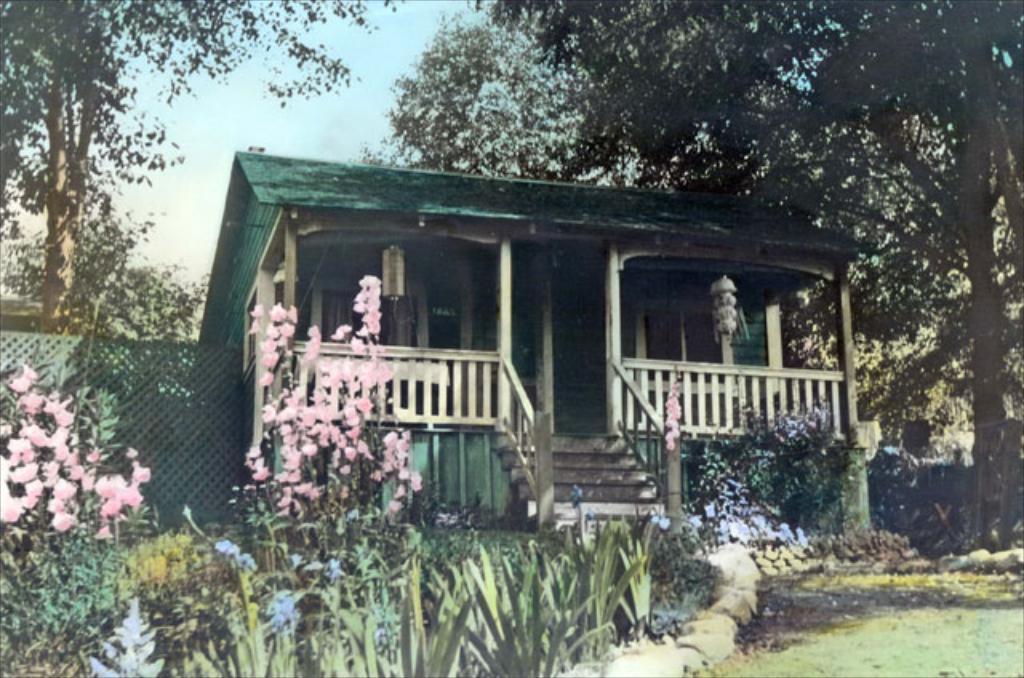Could you give a brief overview of what you see in this image? As we can see in the image there is a house, grass, plants, flowers and trees. On the top there is a sky. 